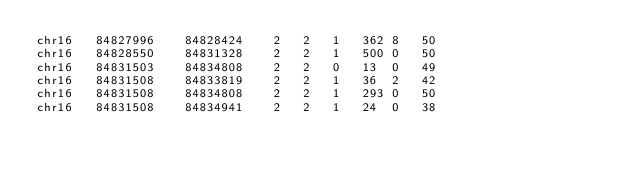Convert code to text. <code><loc_0><loc_0><loc_500><loc_500><_SQL_>chr16	84827996	84828424	2	2	1	362	8	50
chr16	84828550	84831328	2	2	1	500	0	50
chr16	84831503	84834808	2	2	0	13	0	49
chr16	84831508	84833819	2	2	1	36	2	42
chr16	84831508	84834808	2	2	1	293	0	50
chr16	84831508	84834941	2	2	1	24	0	38</code> 